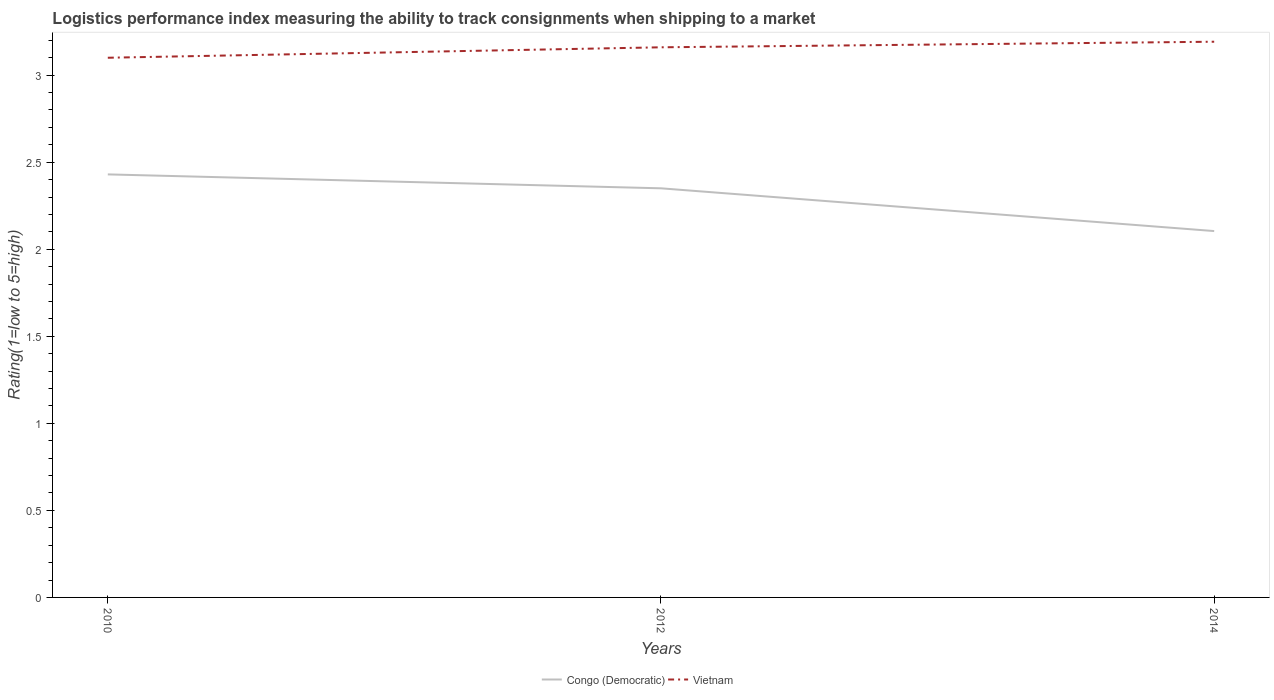How many different coloured lines are there?
Provide a short and direct response. 2. Is the number of lines equal to the number of legend labels?
Keep it short and to the point. Yes. Across all years, what is the maximum Logistic performance index in Congo (Democratic)?
Provide a succinct answer. 2.1. What is the total Logistic performance index in Congo (Democratic) in the graph?
Provide a succinct answer. 0.08. What is the difference between the highest and the second highest Logistic performance index in Vietnam?
Give a very brief answer. 0.09. What is the difference between the highest and the lowest Logistic performance index in Congo (Democratic)?
Ensure brevity in your answer.  2. How many lines are there?
Offer a very short reply. 2. Are the values on the major ticks of Y-axis written in scientific E-notation?
Make the answer very short. No. Does the graph contain any zero values?
Provide a short and direct response. No. Where does the legend appear in the graph?
Offer a terse response. Bottom center. How many legend labels are there?
Offer a very short reply. 2. How are the legend labels stacked?
Give a very brief answer. Horizontal. What is the title of the graph?
Your answer should be compact. Logistics performance index measuring the ability to track consignments when shipping to a market. What is the label or title of the X-axis?
Give a very brief answer. Years. What is the label or title of the Y-axis?
Ensure brevity in your answer.  Rating(1=low to 5=high). What is the Rating(1=low to 5=high) in Congo (Democratic) in 2010?
Offer a terse response. 2.43. What is the Rating(1=low to 5=high) of Congo (Democratic) in 2012?
Your answer should be compact. 2.35. What is the Rating(1=low to 5=high) of Vietnam in 2012?
Your answer should be very brief. 3.16. What is the Rating(1=low to 5=high) in Congo (Democratic) in 2014?
Your answer should be compact. 2.1. What is the Rating(1=low to 5=high) in Vietnam in 2014?
Keep it short and to the point. 3.19. Across all years, what is the maximum Rating(1=low to 5=high) in Congo (Democratic)?
Your answer should be compact. 2.43. Across all years, what is the maximum Rating(1=low to 5=high) of Vietnam?
Provide a succinct answer. 3.19. Across all years, what is the minimum Rating(1=low to 5=high) in Congo (Democratic)?
Ensure brevity in your answer.  2.1. What is the total Rating(1=low to 5=high) in Congo (Democratic) in the graph?
Give a very brief answer. 6.88. What is the total Rating(1=low to 5=high) of Vietnam in the graph?
Offer a terse response. 9.45. What is the difference between the Rating(1=low to 5=high) of Congo (Democratic) in 2010 and that in 2012?
Your response must be concise. 0.08. What is the difference between the Rating(1=low to 5=high) of Vietnam in 2010 and that in 2012?
Ensure brevity in your answer.  -0.06. What is the difference between the Rating(1=low to 5=high) in Congo (Democratic) in 2010 and that in 2014?
Provide a short and direct response. 0.33. What is the difference between the Rating(1=low to 5=high) of Vietnam in 2010 and that in 2014?
Provide a succinct answer. -0.09. What is the difference between the Rating(1=low to 5=high) in Congo (Democratic) in 2012 and that in 2014?
Your answer should be very brief. 0.25. What is the difference between the Rating(1=low to 5=high) in Vietnam in 2012 and that in 2014?
Offer a terse response. -0.03. What is the difference between the Rating(1=low to 5=high) in Congo (Democratic) in 2010 and the Rating(1=low to 5=high) in Vietnam in 2012?
Offer a terse response. -0.73. What is the difference between the Rating(1=low to 5=high) in Congo (Democratic) in 2010 and the Rating(1=low to 5=high) in Vietnam in 2014?
Your answer should be compact. -0.76. What is the difference between the Rating(1=low to 5=high) in Congo (Democratic) in 2012 and the Rating(1=low to 5=high) in Vietnam in 2014?
Offer a terse response. -0.84. What is the average Rating(1=low to 5=high) in Congo (Democratic) per year?
Offer a very short reply. 2.29. What is the average Rating(1=low to 5=high) of Vietnam per year?
Keep it short and to the point. 3.15. In the year 2010, what is the difference between the Rating(1=low to 5=high) of Congo (Democratic) and Rating(1=low to 5=high) of Vietnam?
Your answer should be compact. -0.67. In the year 2012, what is the difference between the Rating(1=low to 5=high) in Congo (Democratic) and Rating(1=low to 5=high) in Vietnam?
Give a very brief answer. -0.81. In the year 2014, what is the difference between the Rating(1=low to 5=high) in Congo (Democratic) and Rating(1=low to 5=high) in Vietnam?
Your answer should be compact. -1.09. What is the ratio of the Rating(1=low to 5=high) in Congo (Democratic) in 2010 to that in 2012?
Your response must be concise. 1.03. What is the ratio of the Rating(1=low to 5=high) in Congo (Democratic) in 2010 to that in 2014?
Provide a short and direct response. 1.15. What is the ratio of the Rating(1=low to 5=high) of Vietnam in 2010 to that in 2014?
Your answer should be compact. 0.97. What is the ratio of the Rating(1=low to 5=high) of Congo (Democratic) in 2012 to that in 2014?
Your answer should be very brief. 1.12. What is the ratio of the Rating(1=low to 5=high) of Vietnam in 2012 to that in 2014?
Your response must be concise. 0.99. What is the difference between the highest and the second highest Rating(1=low to 5=high) of Vietnam?
Provide a short and direct response. 0.03. What is the difference between the highest and the lowest Rating(1=low to 5=high) of Congo (Democratic)?
Your answer should be compact. 0.33. What is the difference between the highest and the lowest Rating(1=low to 5=high) of Vietnam?
Offer a terse response. 0.09. 